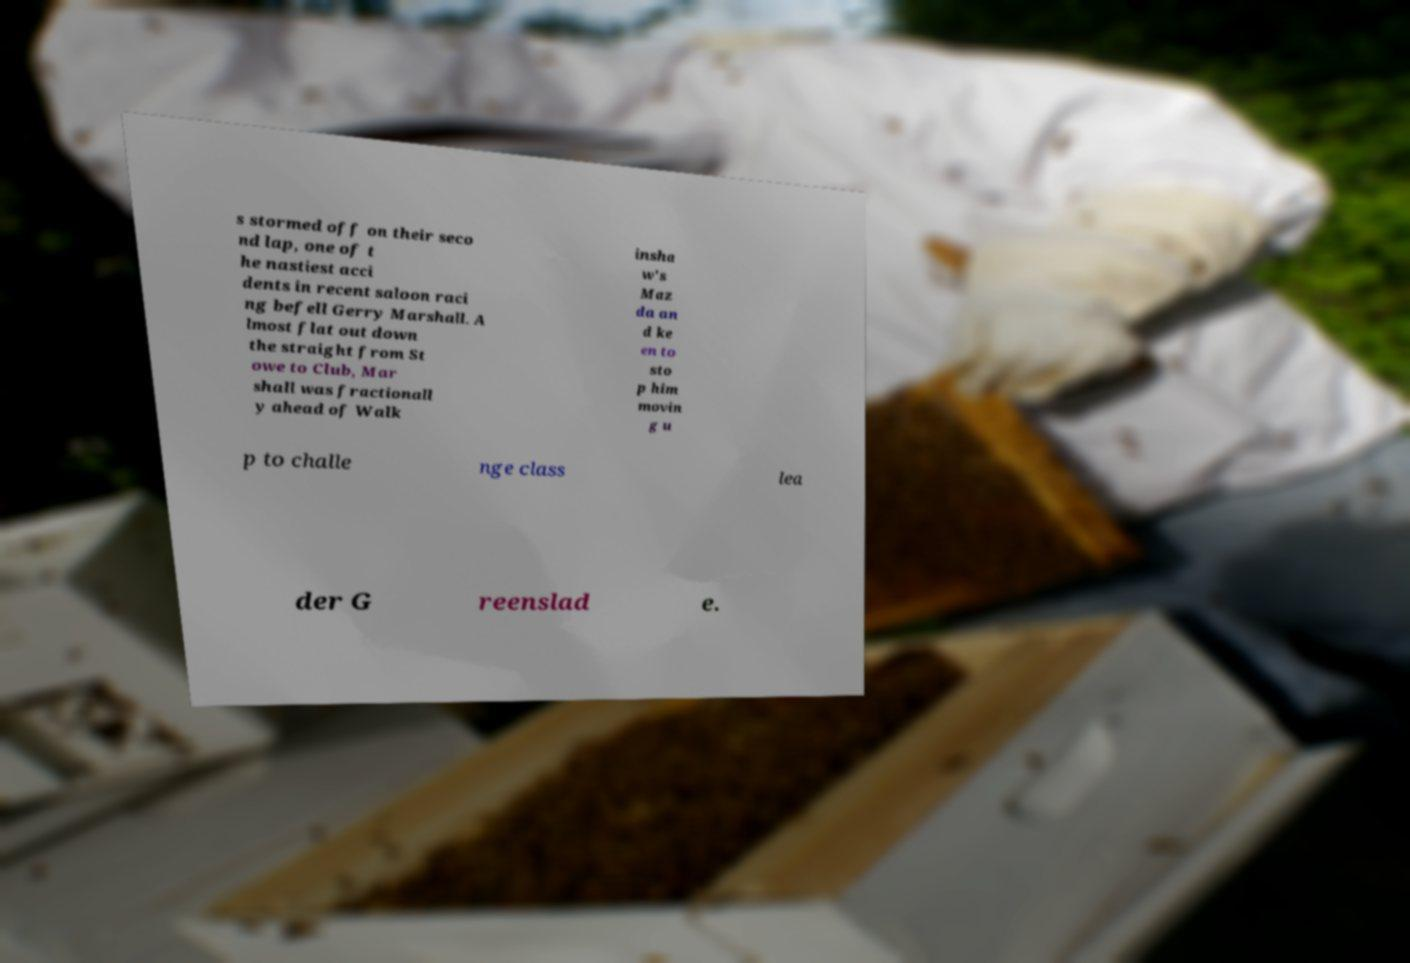What messages or text are displayed in this image? I need them in a readable, typed format. s stormed off on their seco nd lap, one of t he nastiest acci dents in recent saloon raci ng befell Gerry Marshall. A lmost flat out down the straight from St owe to Club, Mar shall was fractionall y ahead of Walk insha w's Maz da an d ke en to sto p him movin g u p to challe nge class lea der G reenslad e. 